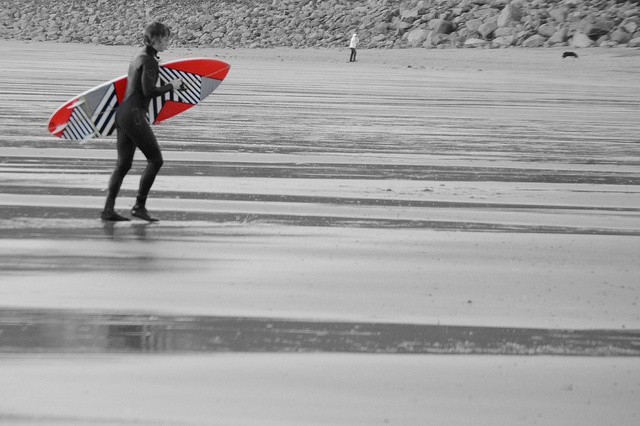Describe the objects in this image and their specific colors. I can see people in gray, black, darkgray, and lightgray tones, surfboard in gray, darkgray, brown, and black tones, people in gray, darkgray, lightgray, and black tones, and dog in gray, darkgray, and black tones in this image. 